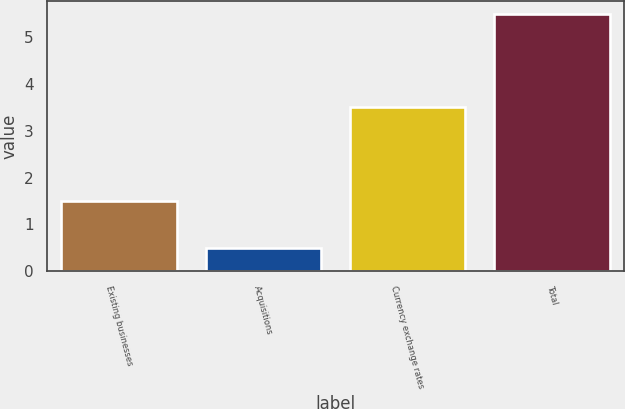<chart> <loc_0><loc_0><loc_500><loc_500><bar_chart><fcel>Existing businesses<fcel>Acquisitions<fcel>Currency exchange rates<fcel>Total<nl><fcel>1.5<fcel>0.5<fcel>3.5<fcel>5.5<nl></chart> 